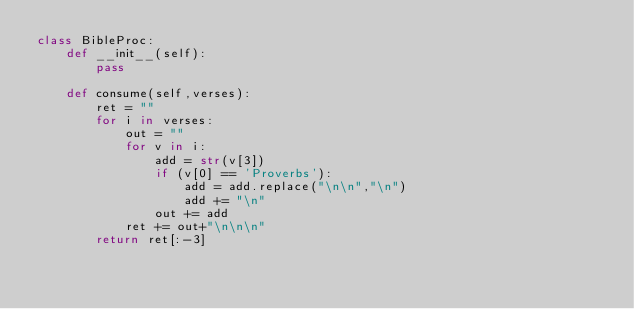Convert code to text. <code><loc_0><loc_0><loc_500><loc_500><_Python_>class BibleProc:
	def __init__(self):
		pass

	def consume(self,verses):
		ret = ""
		for i in verses:
			out = ""
			for v in i:
				add = str(v[3])
				if (v[0] == 'Proverbs'):
					add = add.replace("\n\n","\n")
					add += "\n"
				out += add
			ret += out+"\n\n\n"
		return ret[:-3]
</code> 